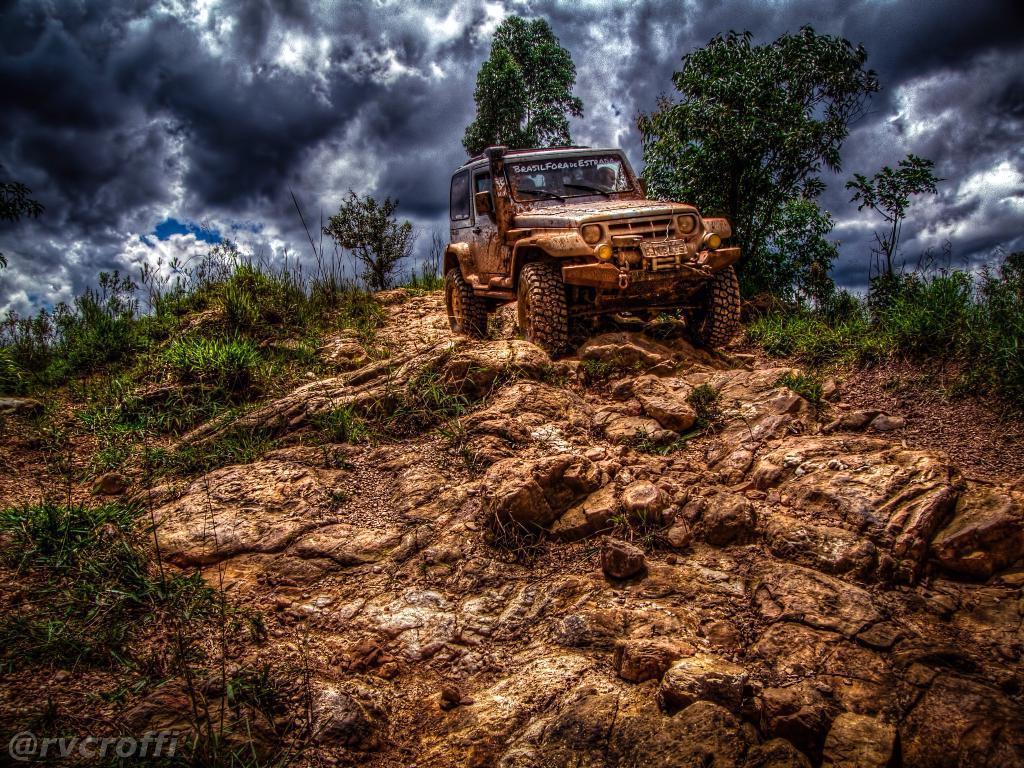Could you give a brief overview of what you see in this image? We can see vehicle, grass, plants and trees. In the background we can see the sky with clouds. In the bottom left side of the image we can see watermark. 